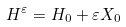<formula> <loc_0><loc_0><loc_500><loc_500>H { ^ { \varepsilon } } = H _ { 0 } + \varepsilon X _ { 0 }</formula> 